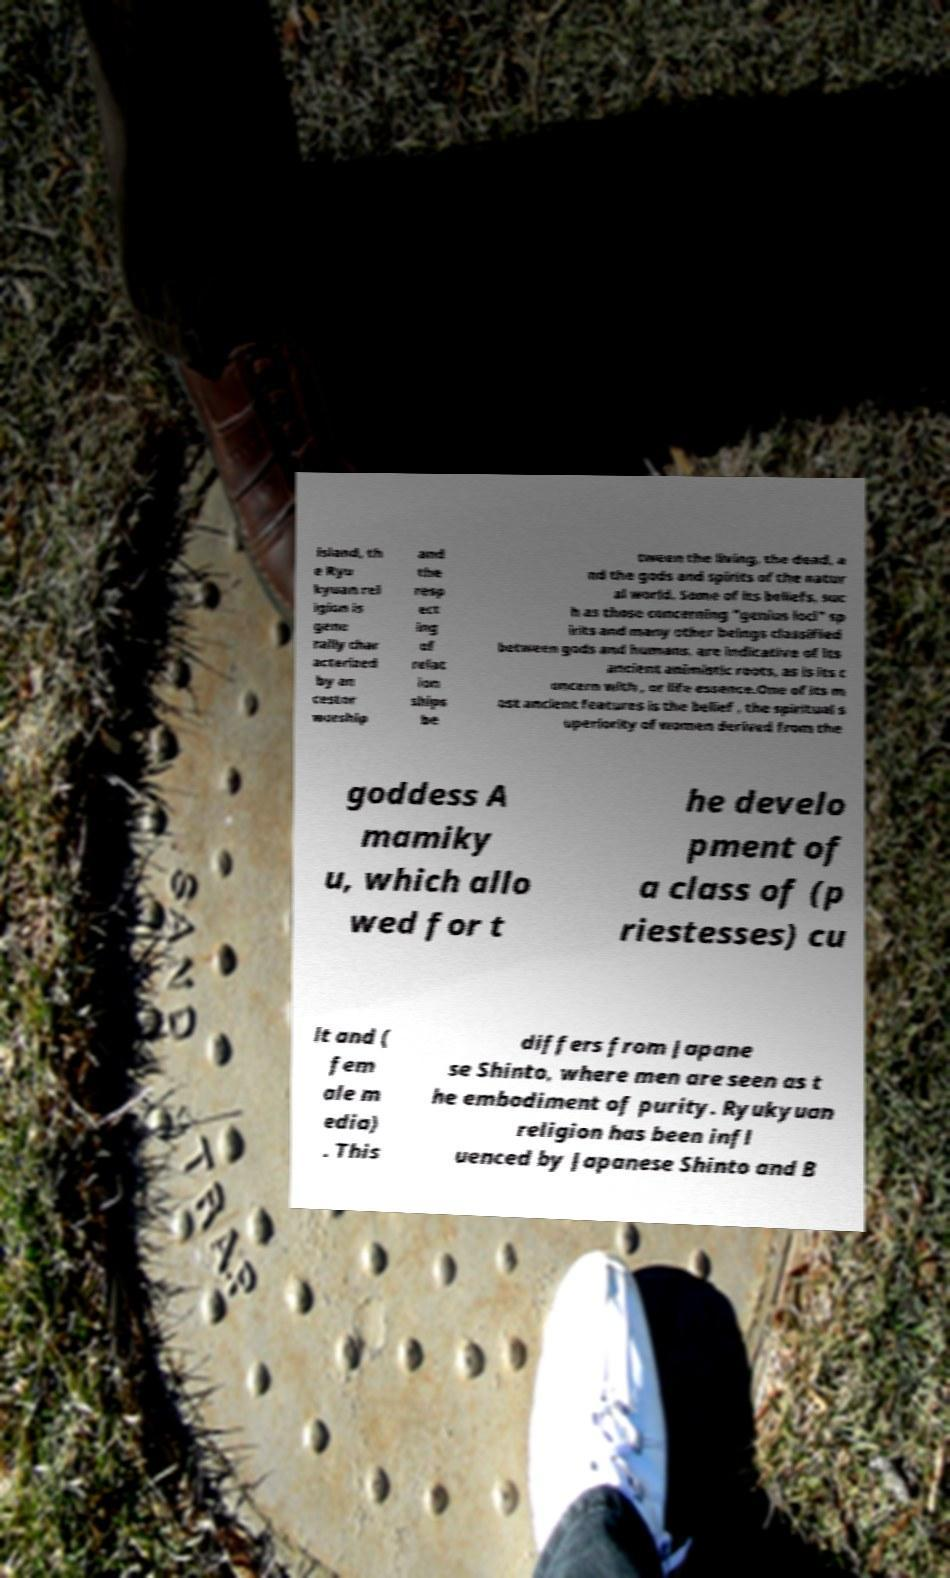There's text embedded in this image that I need extracted. Can you transcribe it verbatim? island, th e Ryu kyuan rel igion is gene rally char acterized by an cestor worship and the resp ect ing of relat ion ships be tween the living, the dead, a nd the gods and spirits of the natur al world. Some of its beliefs, suc h as those concerning "genius loci" sp irits and many other beings classified between gods and humans, are indicative of its ancient animistic roots, as is its c oncern with , or life essence.One of its m ost ancient features is the belief , the spiritual s uperiority of women derived from the goddess A mamiky u, which allo wed for t he develo pment of a class of (p riestesses) cu lt and ( fem ale m edia) . This differs from Japane se Shinto, where men are seen as t he embodiment of purity. Ryukyuan religion has been infl uenced by Japanese Shinto and B 